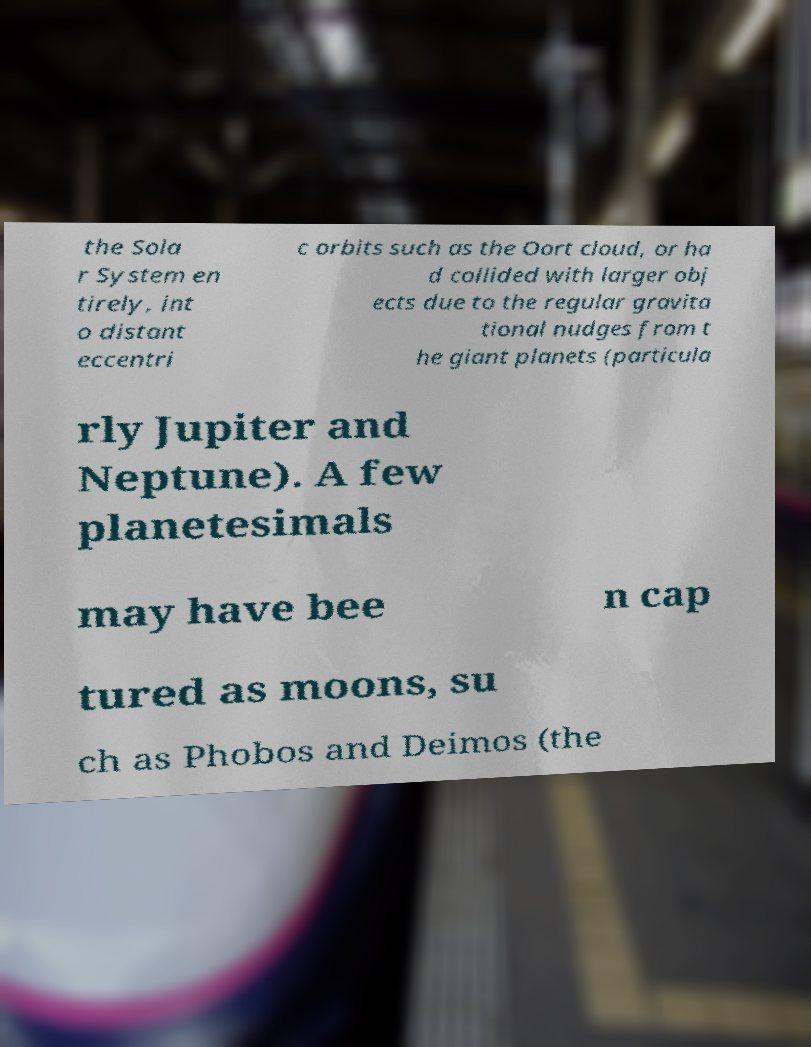There's text embedded in this image that I need extracted. Can you transcribe it verbatim? the Sola r System en tirely, int o distant eccentri c orbits such as the Oort cloud, or ha d collided with larger obj ects due to the regular gravita tional nudges from t he giant planets (particula rly Jupiter and Neptune). A few planetesimals may have bee n cap tured as moons, su ch as Phobos and Deimos (the 